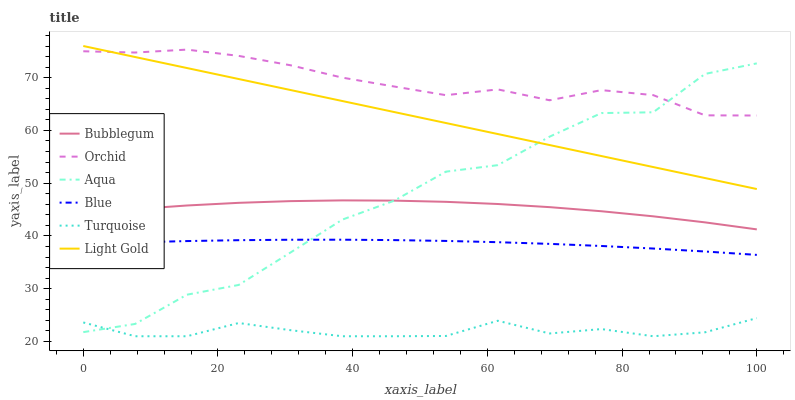Does Aqua have the minimum area under the curve?
Answer yes or no. No. Does Aqua have the maximum area under the curve?
Answer yes or no. No. Is Turquoise the smoothest?
Answer yes or no. No. Is Turquoise the roughest?
Answer yes or no. No. Does Aqua have the lowest value?
Answer yes or no. No. Does Aqua have the highest value?
Answer yes or no. No. Is Blue less than Bubblegum?
Answer yes or no. Yes. Is Orchid greater than Bubblegum?
Answer yes or no. Yes. Does Blue intersect Bubblegum?
Answer yes or no. No. 